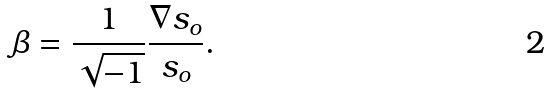Convert formula to latex. <formula><loc_0><loc_0><loc_500><loc_500>\beta = \frac { 1 } { \sqrt { - 1 } } \frac { \nabla s _ { o } } { s _ { o } } .</formula> 